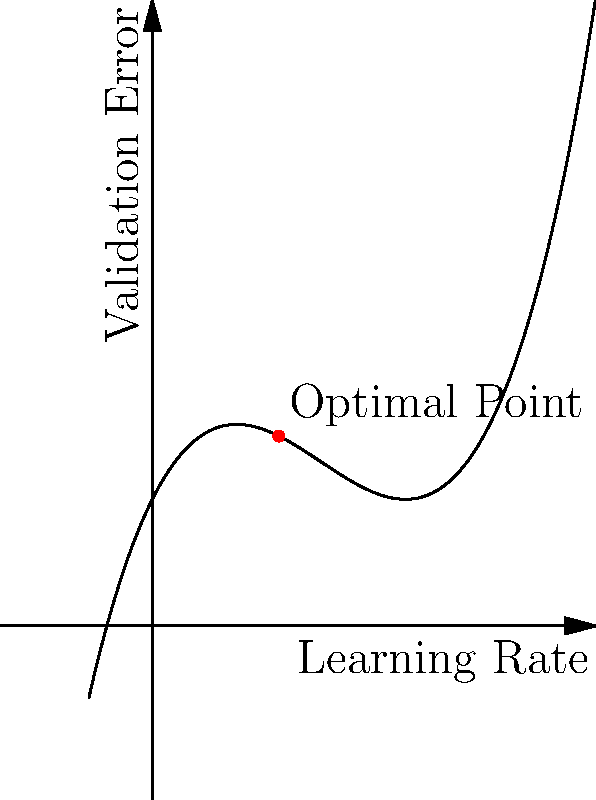In hyperparameter tuning for a machine learning model, you've used polynomial interpolation to model the relationship between the learning rate and validation error. The graph shows this relationship, where the x-axis represents the learning rate and the y-axis represents the validation error. Based on the polynomial curve, what is the approximate optimal learning rate that minimizes the validation error? To find the optimal learning rate, we need to follow these steps:

1. Observe the graph: The curve represents the relationship between the learning rate (x-axis) and the validation error (y-axis).

2. Identify the minimum point: The lowest point on the curve corresponds to the minimum validation error.

3. Locate the x-coordinate: The x-coordinate of this minimum point represents the optimal learning rate.

4. Estimate the value: From the graph, we can see that the minimum point occurs at approximately x = 1.

5. Interpret the result: This means that a learning rate of around 1 should yield the lowest validation error for our model.

6. Consider practical implications: In practice, we might want to test learning rates slightly below and above this value to ensure we've found the true optimum, as the polynomial interpolation is an approximation.
Answer: 1 